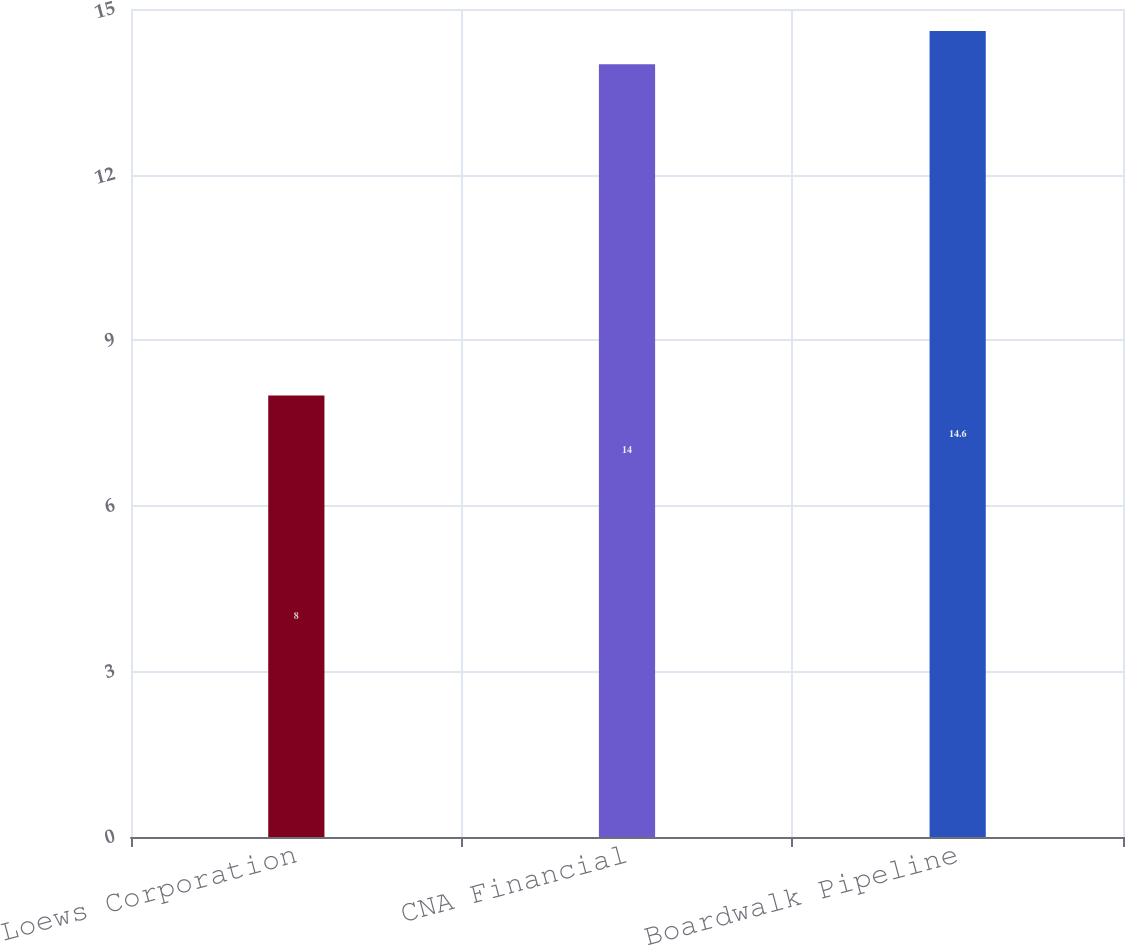Convert chart. <chart><loc_0><loc_0><loc_500><loc_500><bar_chart><fcel>Loews Corporation<fcel>CNA Financial<fcel>Boardwalk Pipeline<nl><fcel>8<fcel>14<fcel>14.6<nl></chart> 